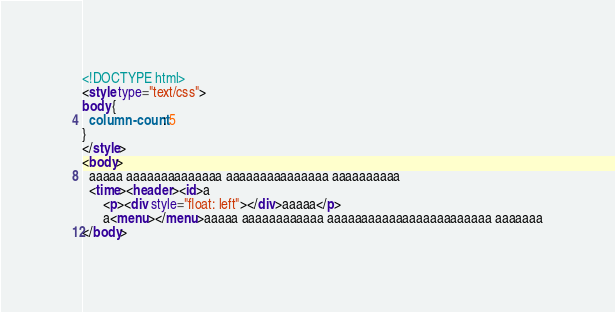Convert code to text. <code><loc_0><loc_0><loc_500><loc_500><_HTML_><!DOCTYPE html>
<style type="text/css">
body {
  column-count: 5
}
</style>
<body>
  aaaaa aaaaaaaaaaaaaa aaaaaaaaaaaaaaa aaaaaaaaaa
  <time><header><id>a
      <p><div style="float: left"></div>aaaaa</p>
      a<menu></menu>aaaaa aaaaaaaaaaaa aaaaaaaaaaaaaaaaaaaaaaaa aaaaaaa
</body>
</code> 